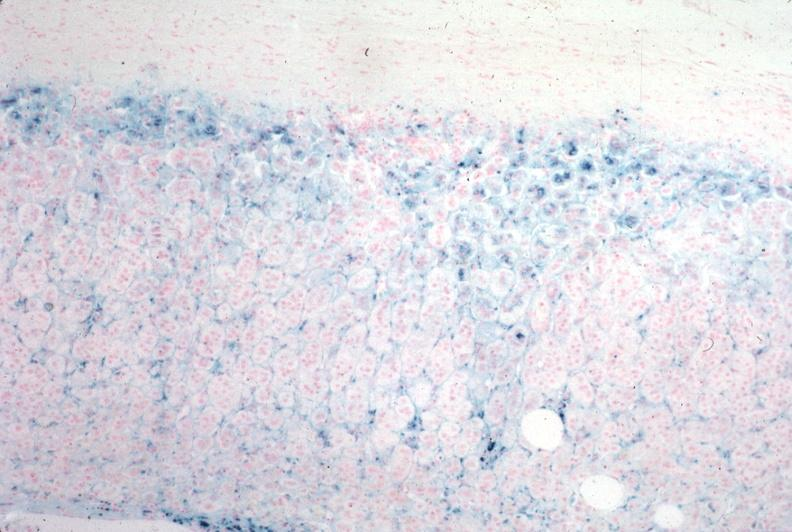s case of peritonitis slide present?
Answer the question using a single word or phrase. No 